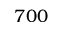<formula> <loc_0><loc_0><loc_500><loc_500>7 0 0</formula> 